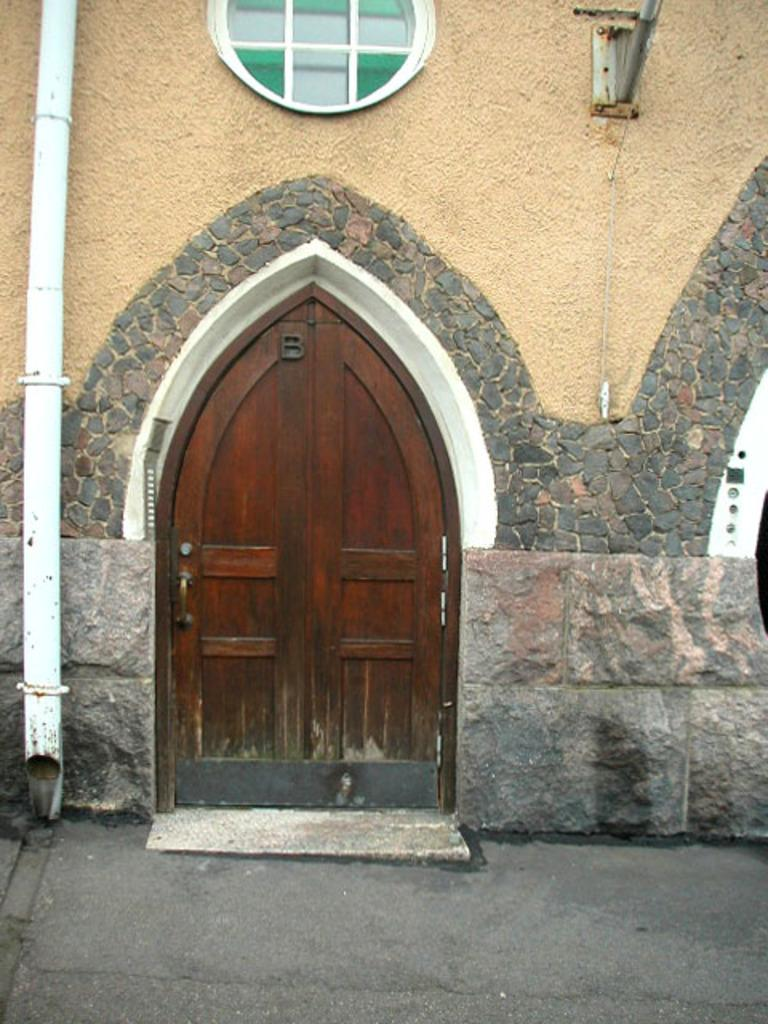What type of structure is visible in the image? There is a building in the image. What are the main features of the building? The building has a door and a window. What else can be seen in the image besides the building? There is a pipeline and a rod attached to the wall in the image. What type of disease is being treated in the building in the image? There is no indication of a disease or any medical treatment in the image; it simply shows a building with a door, window, pipeline, and a rod attached to the wall. 